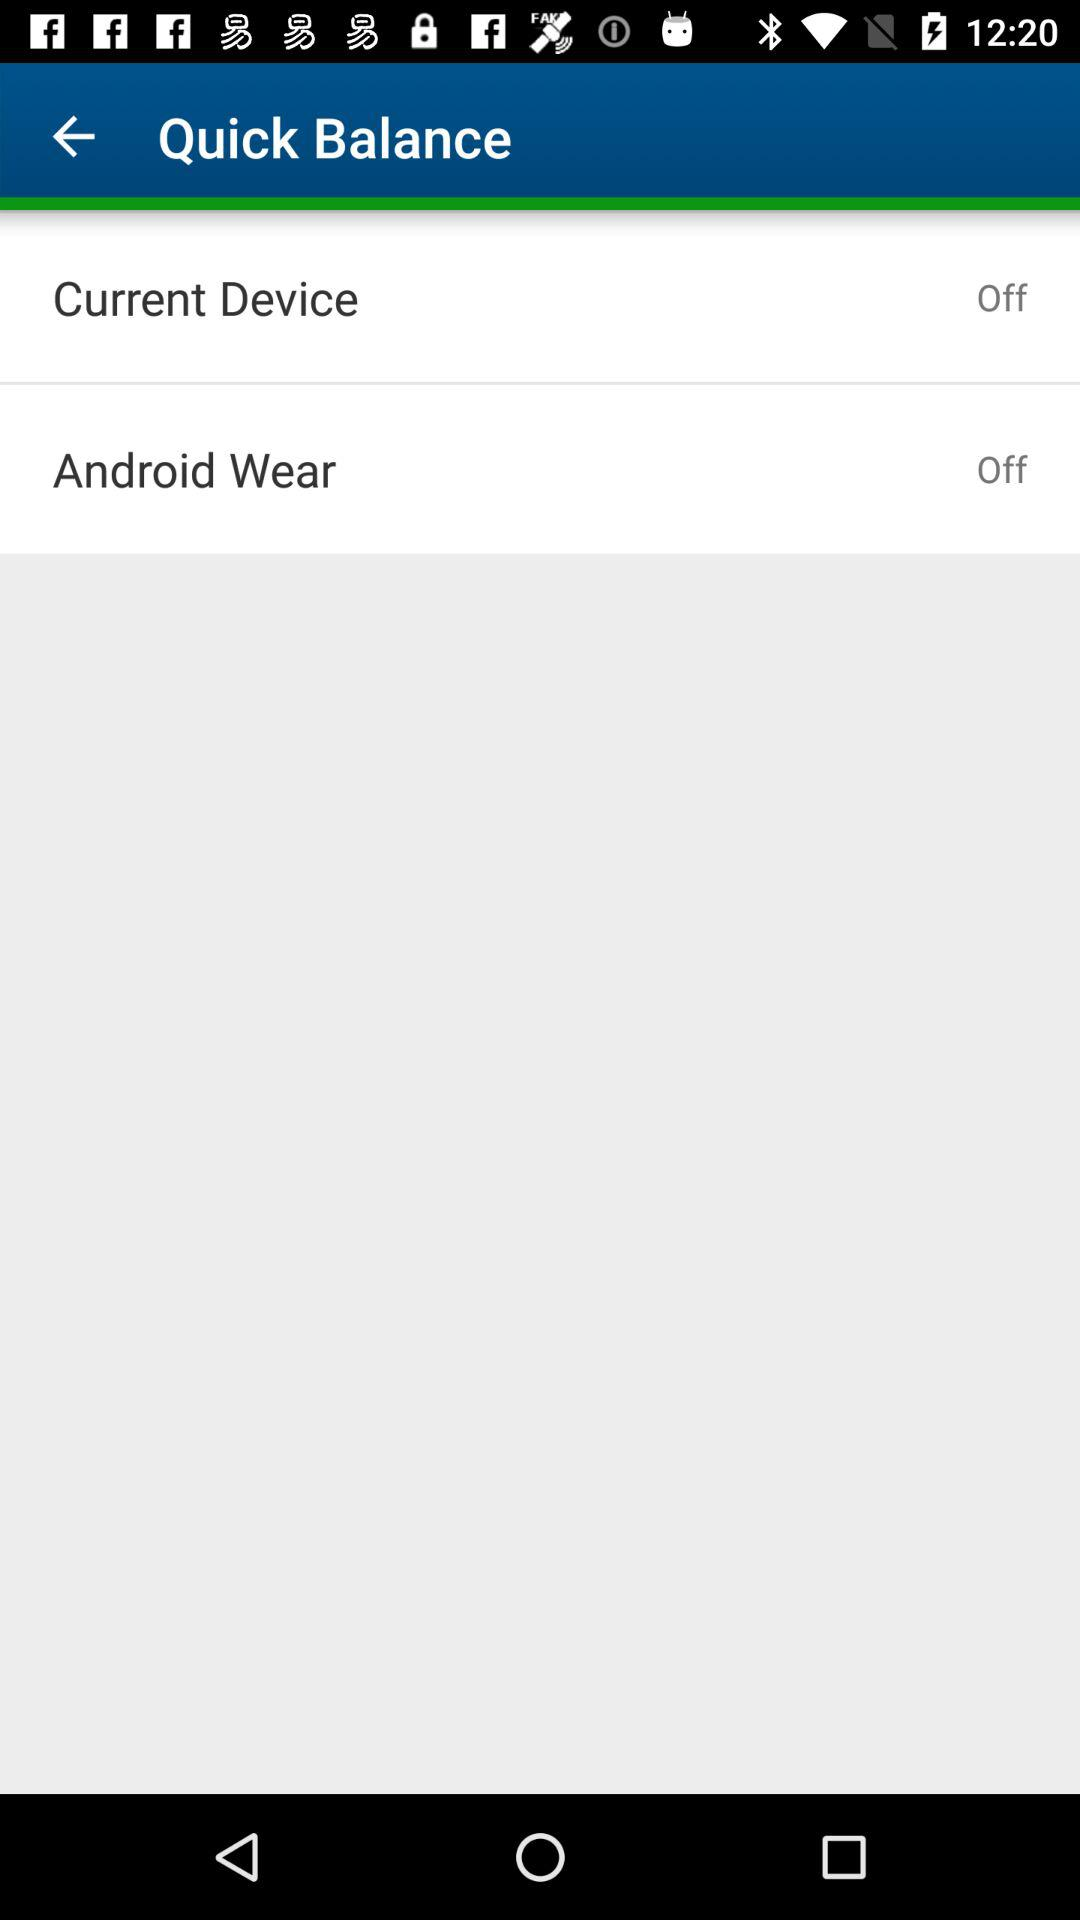What is the status of "Android Wear"? The status of "Android Wear" is "off". 